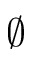<formula> <loc_0><loc_0><loc_500><loc_500>\emptyset</formula> 